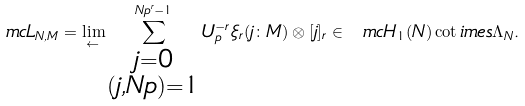<formula> <loc_0><loc_0><loc_500><loc_500>\ m c { L } _ { N , M } = \lim _ { \leftarrow } \sum _ { \substack { j = 0 \\ ( j , N p ) = 1 } } ^ { N p ^ { r } - 1 } U _ { p } ^ { - r } \xi _ { r } ( j \colon M ) \otimes [ j ] _ { r } \in \ m c { H } _ { 1 } ( N ) \cot i m e s \Lambda _ { N } .</formula> 